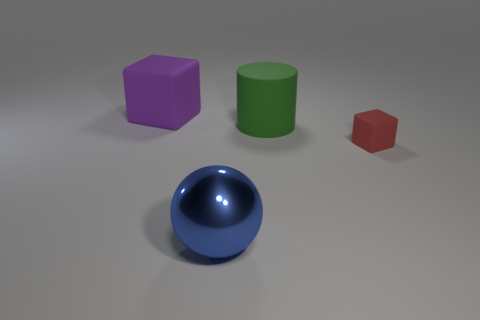There is a object that is to the left of the green matte thing and in front of the purple block; what is its color?
Your answer should be very brief. Blue. How many large things are either cyan metal cylinders or green things?
Offer a very short reply. 1. Is there anything else that is the same color as the big block?
Provide a short and direct response. No. There is a large object to the left of the object in front of the cube right of the big rubber block; what is its material?
Give a very brief answer. Rubber. How many shiny things are large green cylinders or big things?
Your answer should be very brief. 1. What number of yellow things are either big rubber blocks or cylinders?
Offer a terse response. 0. There is a object that is behind the green object; does it have the same color as the large shiny object?
Give a very brief answer. No. Is the big blue ball made of the same material as the purple block?
Your response must be concise. No. Is the number of green matte cylinders left of the large green matte cylinder the same as the number of tiny red objects behind the red cube?
Keep it short and to the point. Yes. There is another purple object that is the same shape as the tiny thing; what material is it?
Your answer should be compact. Rubber. 